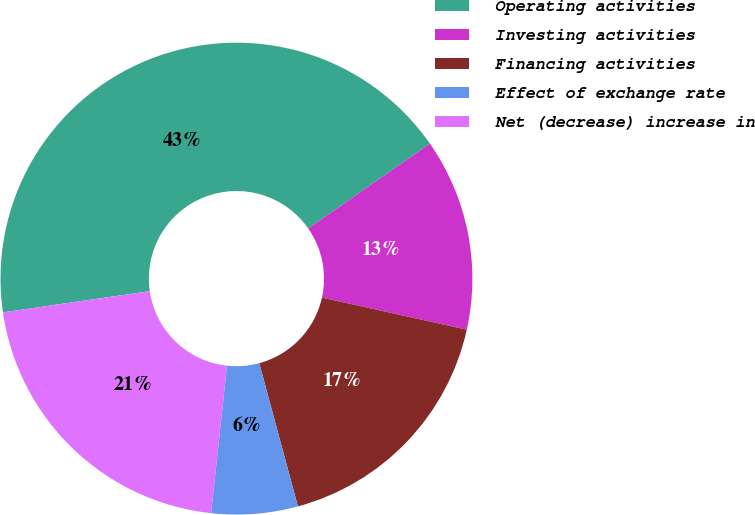Convert chart. <chart><loc_0><loc_0><loc_500><loc_500><pie_chart><fcel>Operating activities<fcel>Investing activities<fcel>Financing activities<fcel>Effect of exchange rate<fcel>Net (decrease) increase in<nl><fcel>42.59%<fcel>13.17%<fcel>17.33%<fcel>5.91%<fcel>21.0%<nl></chart> 